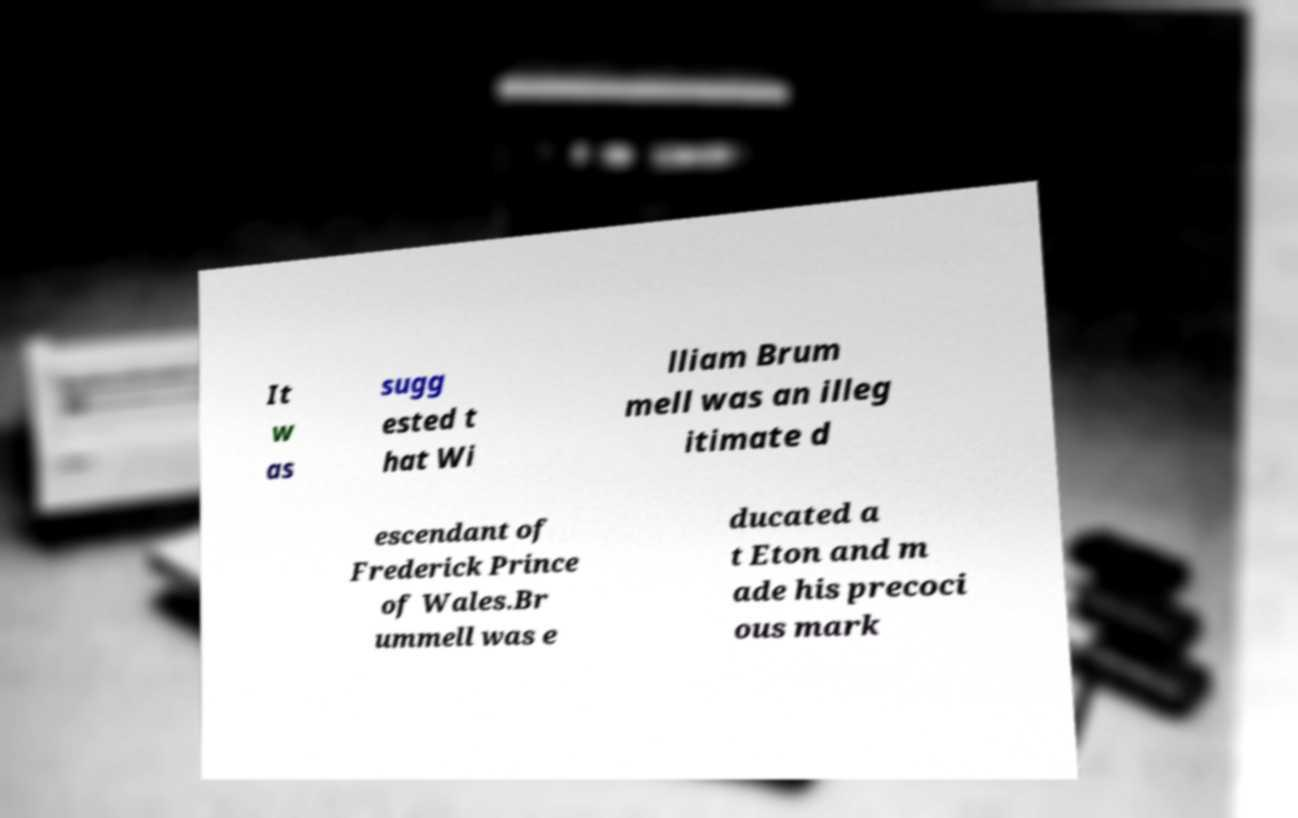Please identify and transcribe the text found in this image. It w as sugg ested t hat Wi lliam Brum mell was an illeg itimate d escendant of Frederick Prince of Wales.Br ummell was e ducated a t Eton and m ade his precoci ous mark 